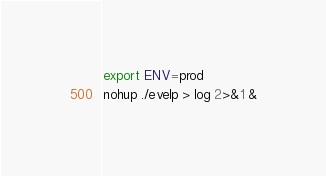<code> <loc_0><loc_0><loc_500><loc_500><_Bash_>export ENV=prod
nohup ./evelp > log 2>&1 &</code> 